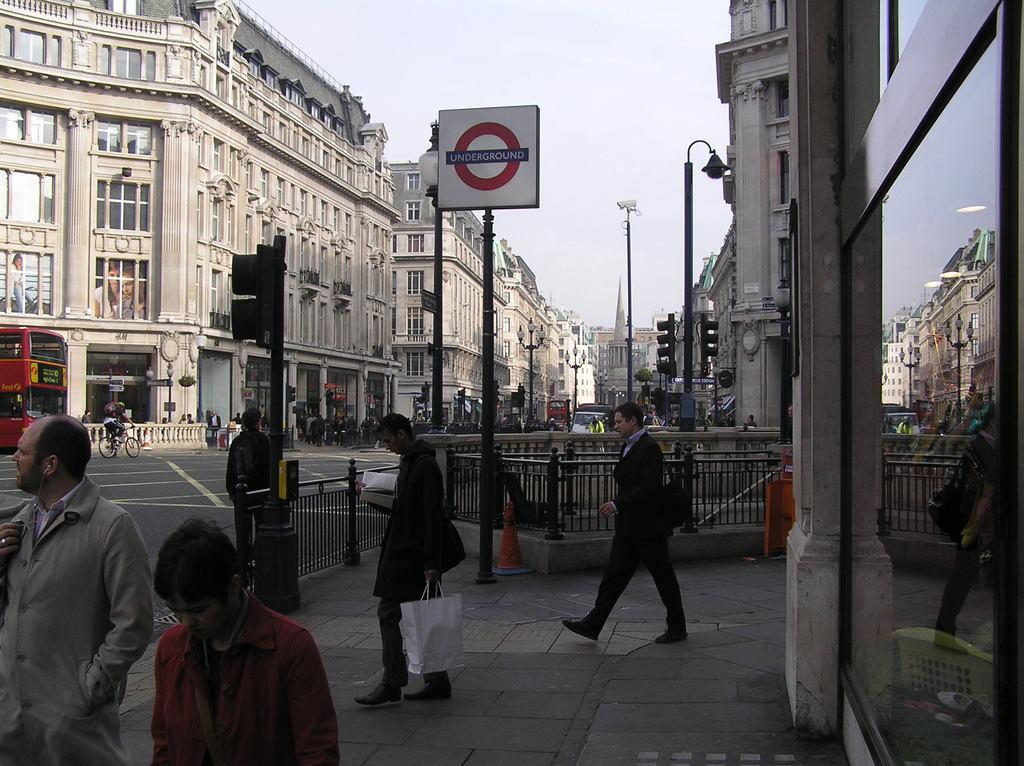Can you describe this image briefly? This image consists of a building. It looks like it is clicked on the road. In the middle, there is a road. There are many persons walking in this image. At the bottom, there is a pavement. At the top, there is a sky. To the left, there is a bus. 